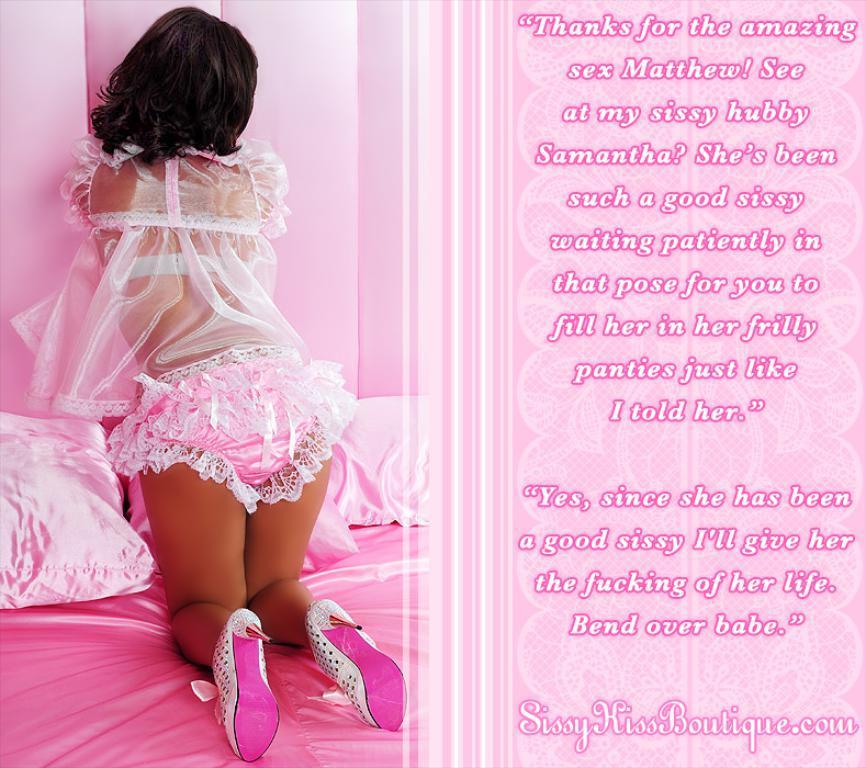In one or two sentences, can you explain what this image depicts? In this image there is a girl standing on the bed, beside that there is some text. 